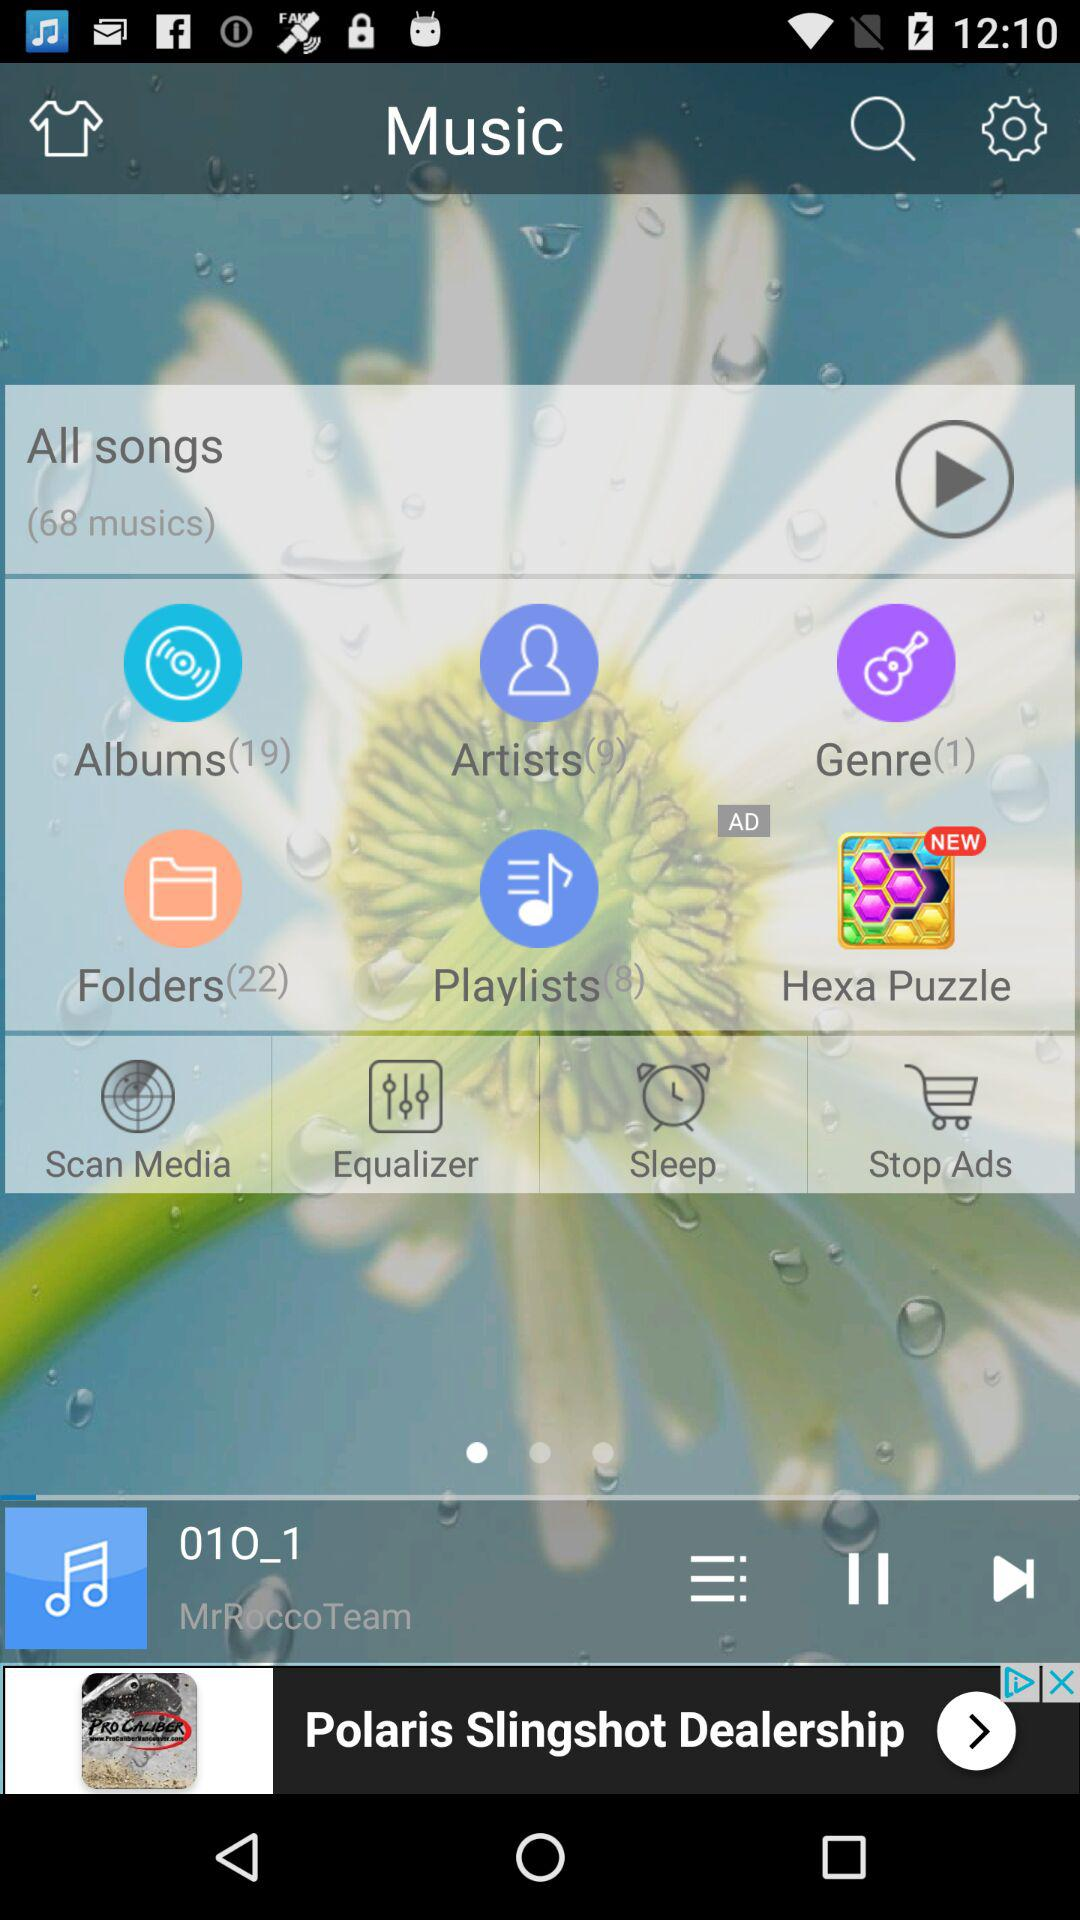Which app is new? The new app is "Hexa Puzzle". 